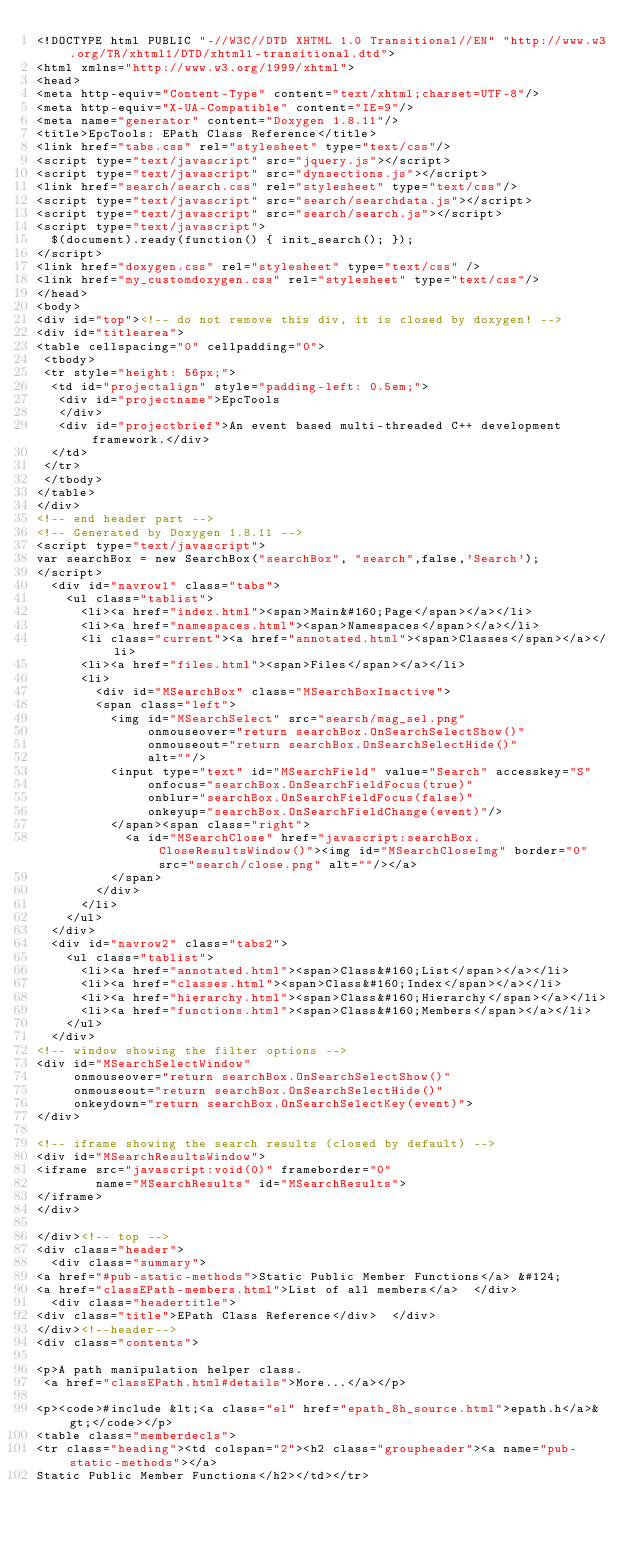Convert code to text. <code><loc_0><loc_0><loc_500><loc_500><_HTML_><!DOCTYPE html PUBLIC "-//W3C//DTD XHTML 1.0 Transitional//EN" "http://www.w3.org/TR/xhtml1/DTD/xhtml1-transitional.dtd">
<html xmlns="http://www.w3.org/1999/xhtml">
<head>
<meta http-equiv="Content-Type" content="text/xhtml;charset=UTF-8"/>
<meta http-equiv="X-UA-Compatible" content="IE=9"/>
<meta name="generator" content="Doxygen 1.8.11"/>
<title>EpcTools: EPath Class Reference</title>
<link href="tabs.css" rel="stylesheet" type="text/css"/>
<script type="text/javascript" src="jquery.js"></script>
<script type="text/javascript" src="dynsections.js"></script>
<link href="search/search.css" rel="stylesheet" type="text/css"/>
<script type="text/javascript" src="search/searchdata.js"></script>
<script type="text/javascript" src="search/search.js"></script>
<script type="text/javascript">
  $(document).ready(function() { init_search(); });
</script>
<link href="doxygen.css" rel="stylesheet" type="text/css" />
<link href="my_customdoxygen.css" rel="stylesheet" type="text/css"/>
</head>
<body>
<div id="top"><!-- do not remove this div, it is closed by doxygen! -->
<div id="titlearea">
<table cellspacing="0" cellpadding="0">
 <tbody>
 <tr style="height: 56px;">
  <td id="projectalign" style="padding-left: 0.5em;">
   <div id="projectname">EpcTools
   </div>
   <div id="projectbrief">An event based multi-threaded C++ development framework.</div>
  </td>
 </tr>
 </tbody>
</table>
</div>
<!-- end header part -->
<!-- Generated by Doxygen 1.8.11 -->
<script type="text/javascript">
var searchBox = new SearchBox("searchBox", "search",false,'Search');
</script>
  <div id="navrow1" class="tabs">
    <ul class="tablist">
      <li><a href="index.html"><span>Main&#160;Page</span></a></li>
      <li><a href="namespaces.html"><span>Namespaces</span></a></li>
      <li class="current"><a href="annotated.html"><span>Classes</span></a></li>
      <li><a href="files.html"><span>Files</span></a></li>
      <li>
        <div id="MSearchBox" class="MSearchBoxInactive">
        <span class="left">
          <img id="MSearchSelect" src="search/mag_sel.png"
               onmouseover="return searchBox.OnSearchSelectShow()"
               onmouseout="return searchBox.OnSearchSelectHide()"
               alt=""/>
          <input type="text" id="MSearchField" value="Search" accesskey="S"
               onfocus="searchBox.OnSearchFieldFocus(true)" 
               onblur="searchBox.OnSearchFieldFocus(false)" 
               onkeyup="searchBox.OnSearchFieldChange(event)"/>
          </span><span class="right">
            <a id="MSearchClose" href="javascript:searchBox.CloseResultsWindow()"><img id="MSearchCloseImg" border="0" src="search/close.png" alt=""/></a>
          </span>
        </div>
      </li>
    </ul>
  </div>
  <div id="navrow2" class="tabs2">
    <ul class="tablist">
      <li><a href="annotated.html"><span>Class&#160;List</span></a></li>
      <li><a href="classes.html"><span>Class&#160;Index</span></a></li>
      <li><a href="hierarchy.html"><span>Class&#160;Hierarchy</span></a></li>
      <li><a href="functions.html"><span>Class&#160;Members</span></a></li>
    </ul>
  </div>
<!-- window showing the filter options -->
<div id="MSearchSelectWindow"
     onmouseover="return searchBox.OnSearchSelectShow()"
     onmouseout="return searchBox.OnSearchSelectHide()"
     onkeydown="return searchBox.OnSearchSelectKey(event)">
</div>

<!-- iframe showing the search results (closed by default) -->
<div id="MSearchResultsWindow">
<iframe src="javascript:void(0)" frameborder="0" 
        name="MSearchResults" id="MSearchResults">
</iframe>
</div>

</div><!-- top -->
<div class="header">
  <div class="summary">
<a href="#pub-static-methods">Static Public Member Functions</a> &#124;
<a href="classEPath-members.html">List of all members</a>  </div>
  <div class="headertitle">
<div class="title">EPath Class Reference</div>  </div>
</div><!--header-->
<div class="contents">

<p>A path manipulation helper class.  
 <a href="classEPath.html#details">More...</a></p>

<p><code>#include &lt;<a class="el" href="epath_8h_source.html">epath.h</a>&gt;</code></p>
<table class="memberdecls">
<tr class="heading"><td colspan="2"><h2 class="groupheader"><a name="pub-static-methods"></a>
Static Public Member Functions</h2></td></tr></code> 